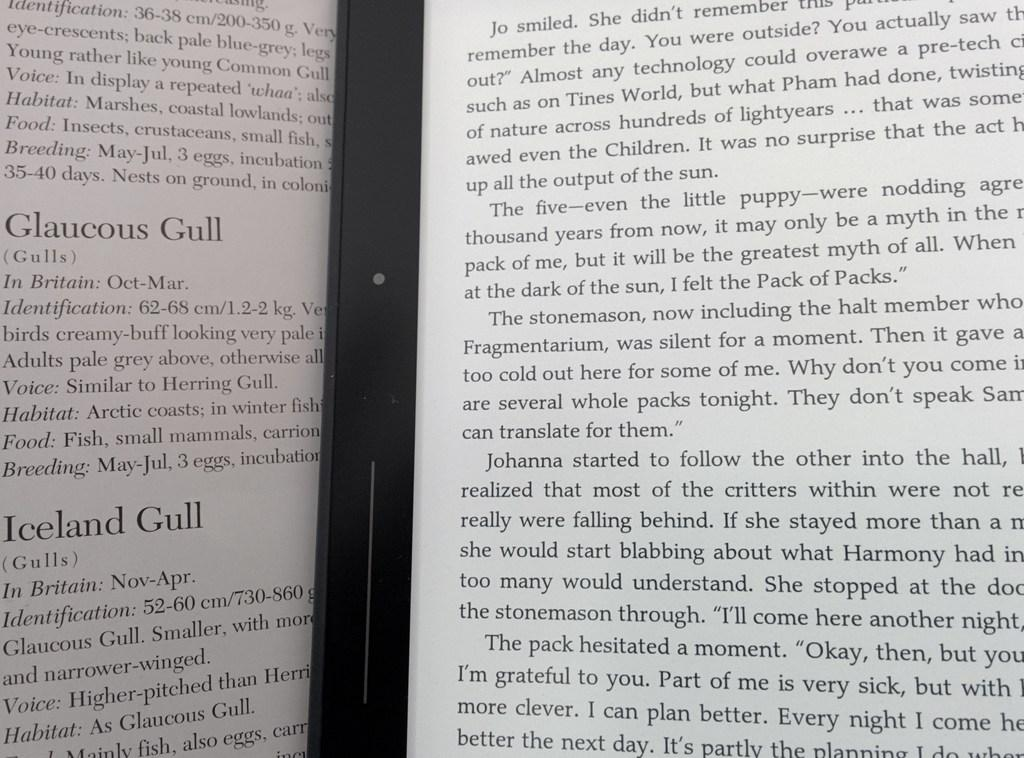<image>
Create a compact narrative representing the image presented. A book is open to a page with the headline Glaucous Gull. 